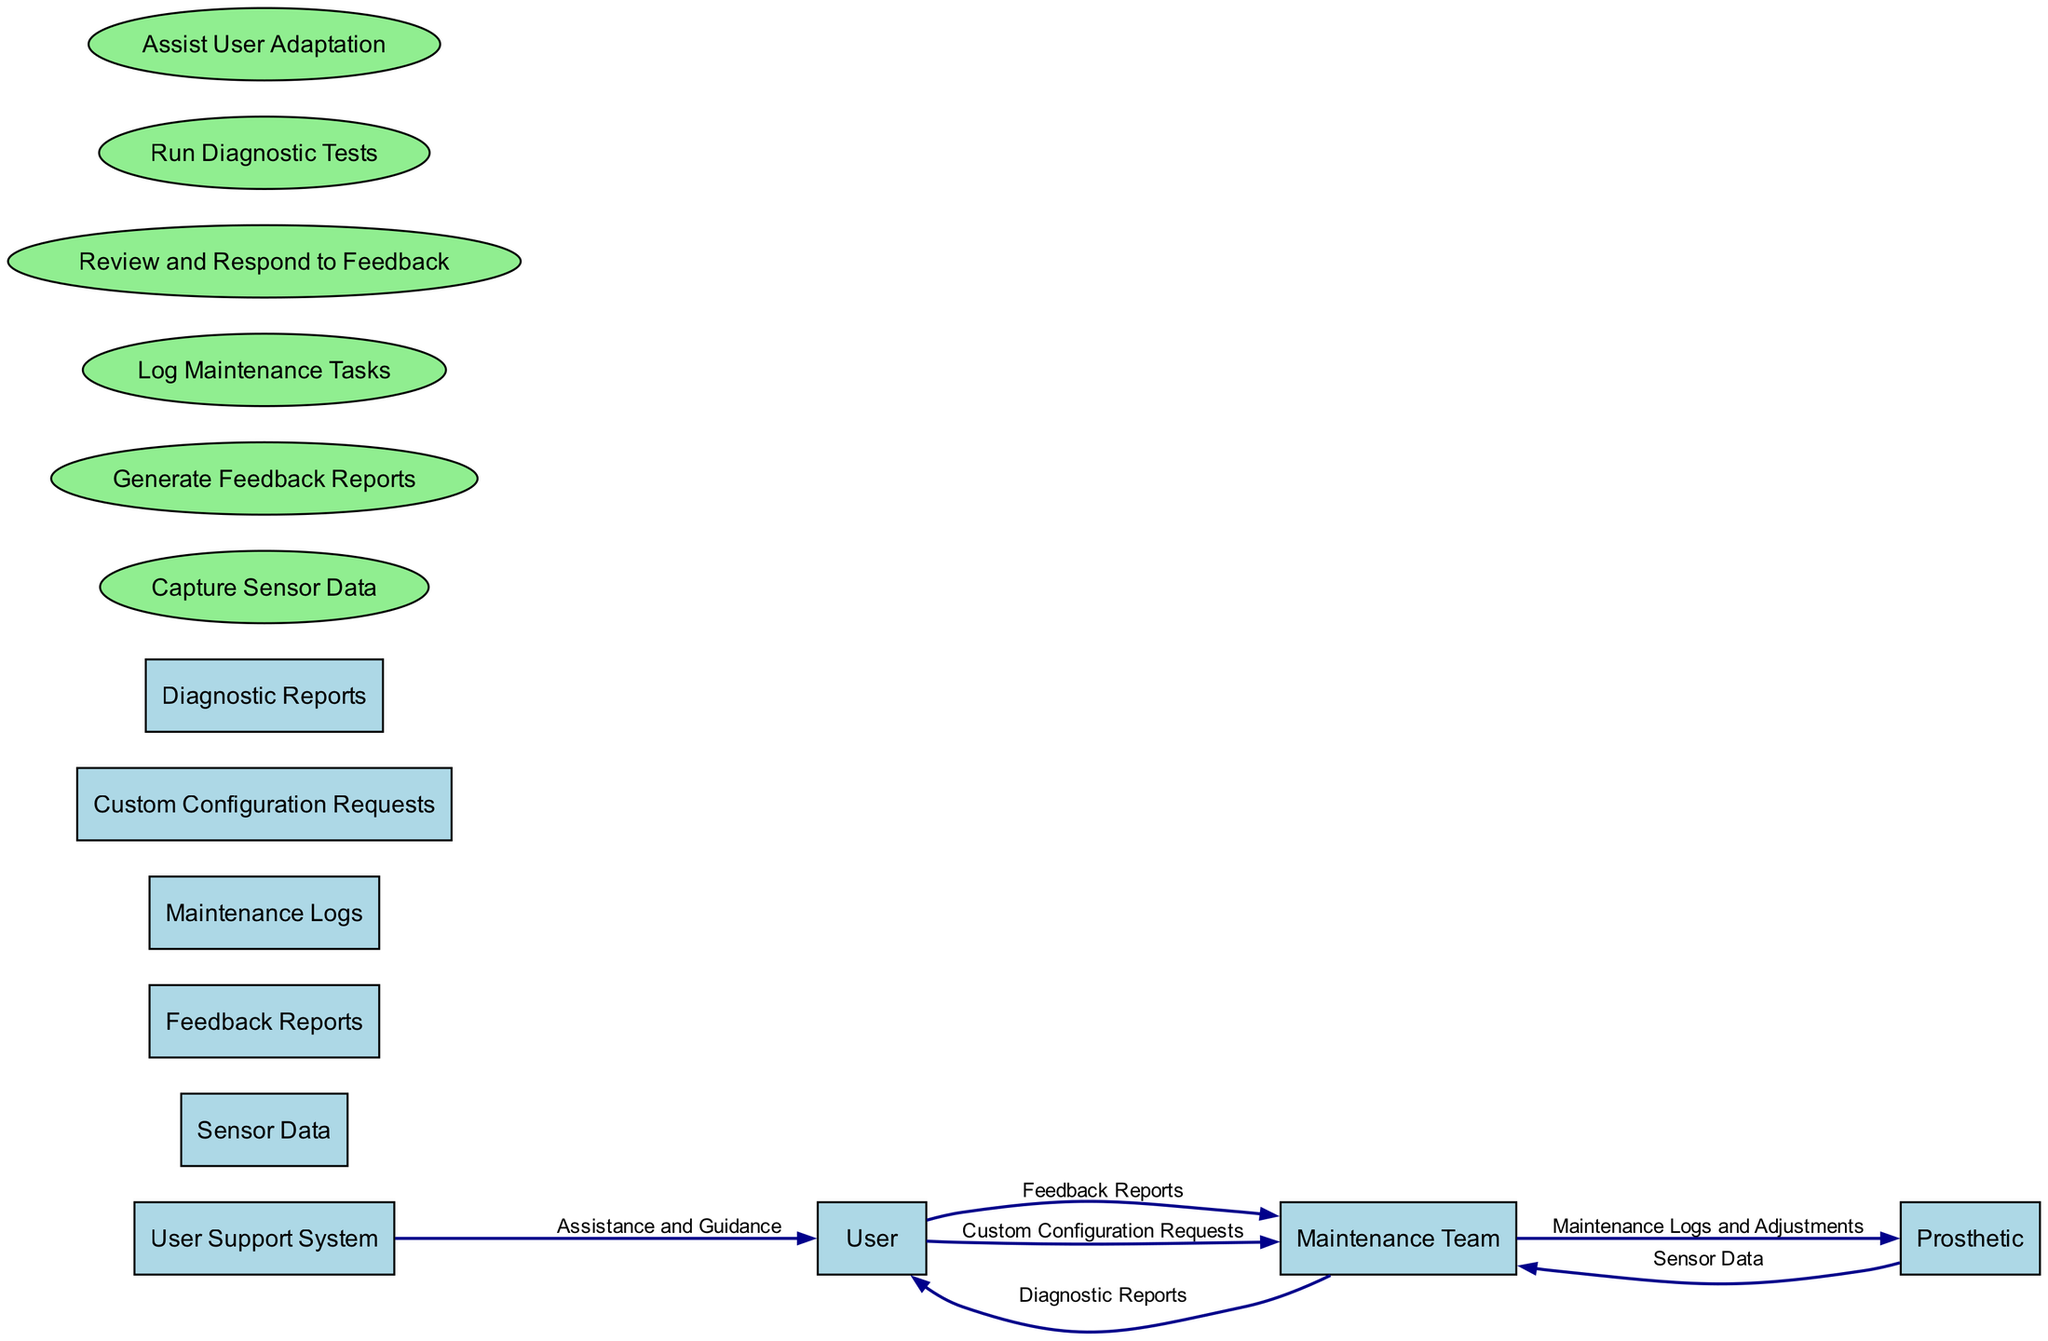What is the role of the Maintenance Team in this diagram? The Maintenance Team is responsible for reviewing and responding to feedback, logging maintenance tasks, running diagnostic tests, and customizing the prosthetic based on user requests.
Answer: Review and respond to feedback How many entities are represented in this diagram? The diagram clearly lists 8 entities, each of which corresponds to a significant component of the communication and feedback process.
Answer: 8 What type of data does the User send to the Maintenance Team? The User sends Feedback Reports and Custom Configuration Requests to the Maintenance Team, both reflecting the User's experiences and needs regarding the prosthetic.
Answer: Feedback Reports and Custom Configuration Requests Which entity is responsible for capturing sensor data? The Prosthetic is equipped with sensors that capture data related to its performance and user interaction, which is then sent to the Maintenance Team for further analysis.
Answer: Prosthetic What happens after the Maintenance Team receives feedback reports from the User? After receiving the feedback, the Maintenance Team performs the process of reviewing and responding to the feedback, which may include adjustments or consultations.
Answer: Review and respond to feedback How does the User Support System contribute to the User's adaptation process? The User Support System provides assistance and guidance to the User, helping them cope psychologically and technically with their new robotic prosthetic.
Answer: Assistance and Guidance What flow connects the Prosthetic to the Maintenance Team? The flow connecting the Prosthetic to the Maintenance Team is the Sensor Data, which provides vital information for maintenance and diagnostics.
Answer: Sensor Data What is documented by the Maintenance Team? The Maintenance Team documents Maintenance Logs, which detail all adjustments, repairs, and updates made to the prosthetic to maintain a record of its condition and modifications.
Answer: Maintenance Logs 